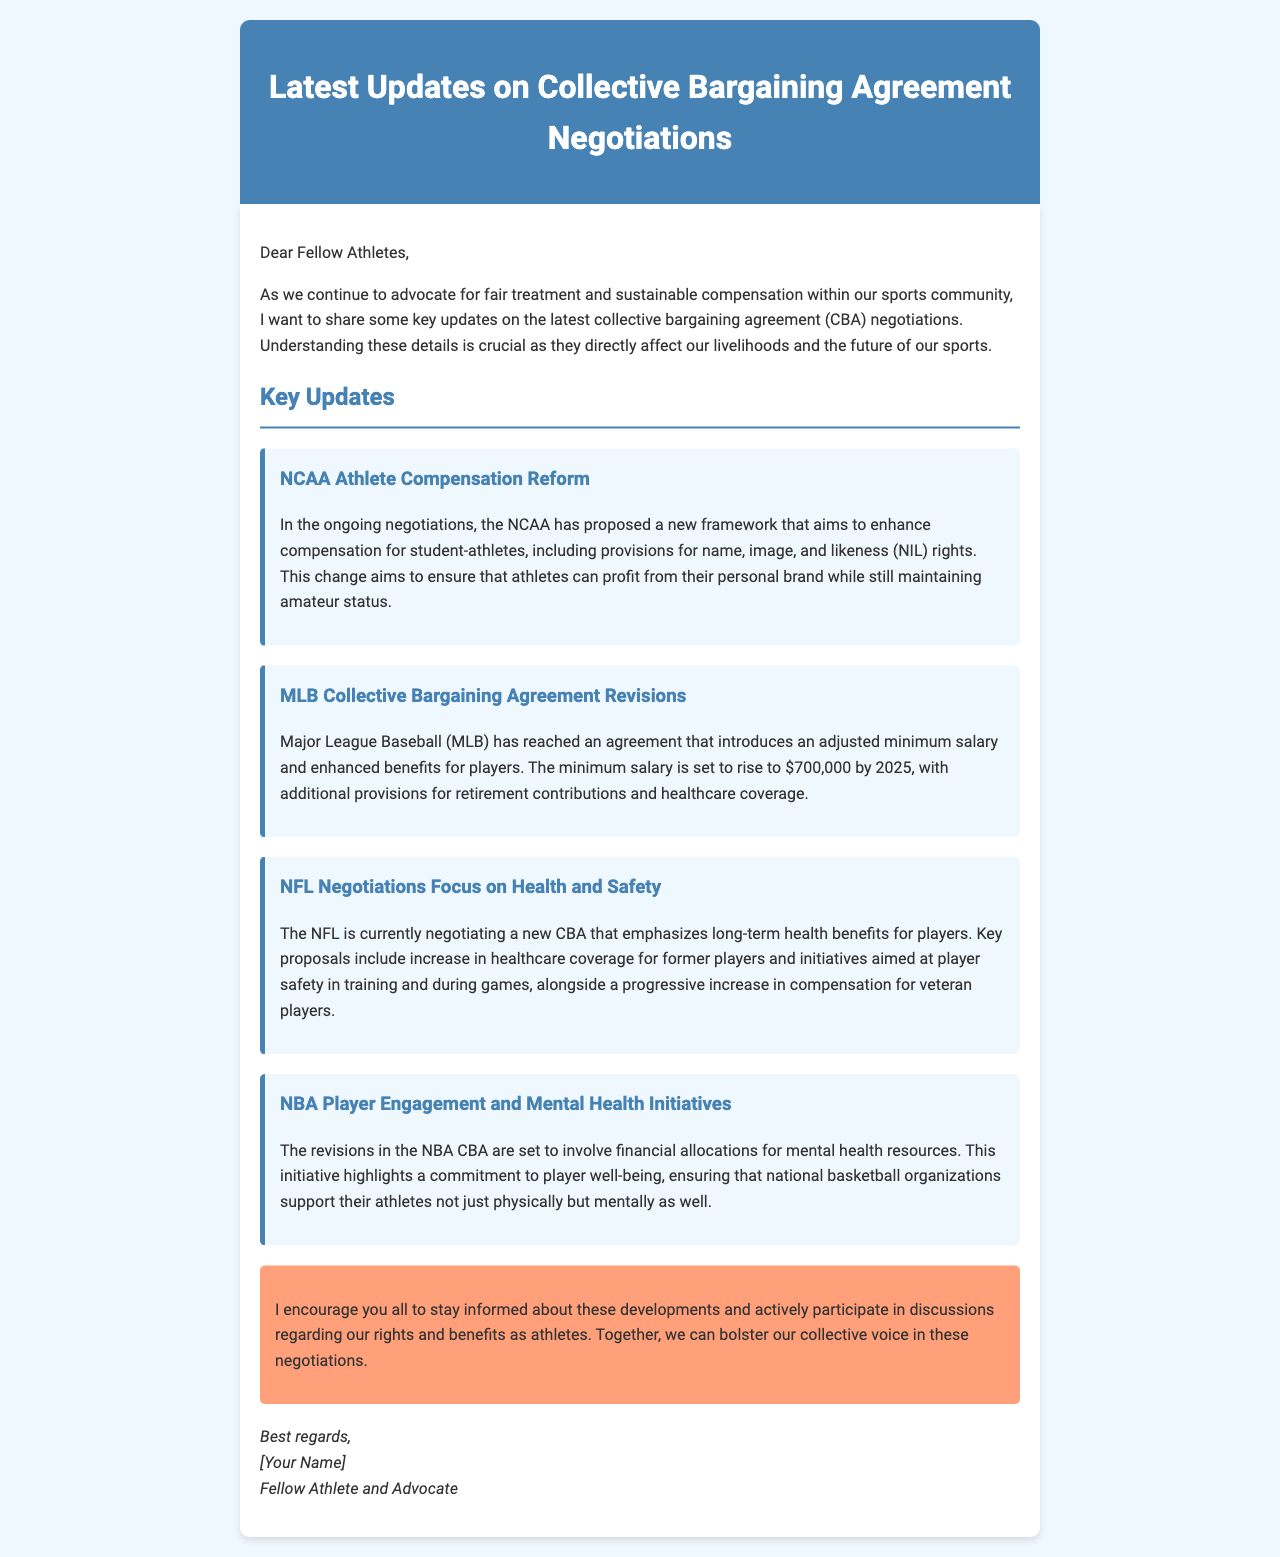What is the minimum salary for MLB players by 2025? The document states that the minimum salary for MLB players is set to rise to $700,000 by 2025.
Answer: $700,000 What is the focus of the NFL negotiations? The NFL negotiations focus on long-term health benefits for players, including healthcare coverage for former players and player safety initiatives.
Answer: Health and Safety Which organization is proposing a framework for name, image, and likeness rights? The NCAA is proposing a new framework to enhance compensation for student-athletes regarding NIL rights.
Answer: NCAA What new initiatives are mentioned in the NBA CBA revisions? The NBA CBA revisions include financial allocations for mental health resources, emphasizing player well-being.
Answer: Mental Health Initiatives What is the primary goal of collective bargaining agreements for athletes? The primary goal of collective bargaining agreements for athletes is to advocate for fair treatment and sustainable compensation.
Answer: Fair treatment and sustainable compensation What year does the document mention for the proposed rise in minimum salary for MLB players? The document specifies that the minimum salary is set to rise by 2025.
Answer: 2025 Who is the author of the document? The document is authored by a fellow athlete and advocate, as indicated at the end of the email.
Answer: [Your Name] What type of document is this? This is an email providing updates on collective bargaining agreement negotiations affecting athlete compensation.
Answer: Email 